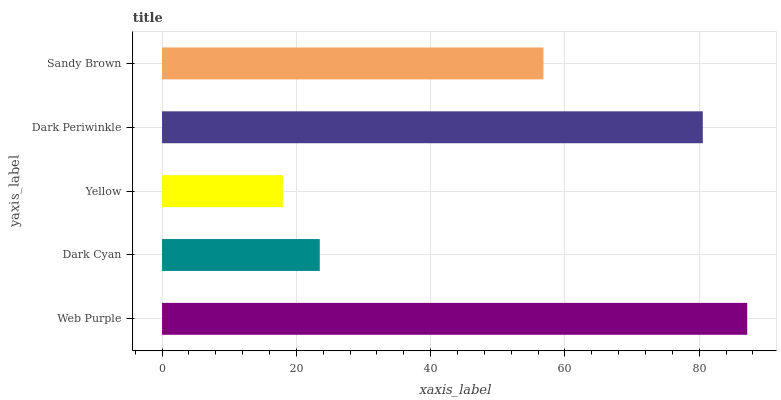Is Yellow the minimum?
Answer yes or no. Yes. Is Web Purple the maximum?
Answer yes or no. Yes. Is Dark Cyan the minimum?
Answer yes or no. No. Is Dark Cyan the maximum?
Answer yes or no. No. Is Web Purple greater than Dark Cyan?
Answer yes or no. Yes. Is Dark Cyan less than Web Purple?
Answer yes or no. Yes. Is Dark Cyan greater than Web Purple?
Answer yes or no. No. Is Web Purple less than Dark Cyan?
Answer yes or no. No. Is Sandy Brown the high median?
Answer yes or no. Yes. Is Sandy Brown the low median?
Answer yes or no. Yes. Is Web Purple the high median?
Answer yes or no. No. Is Web Purple the low median?
Answer yes or no. No. 